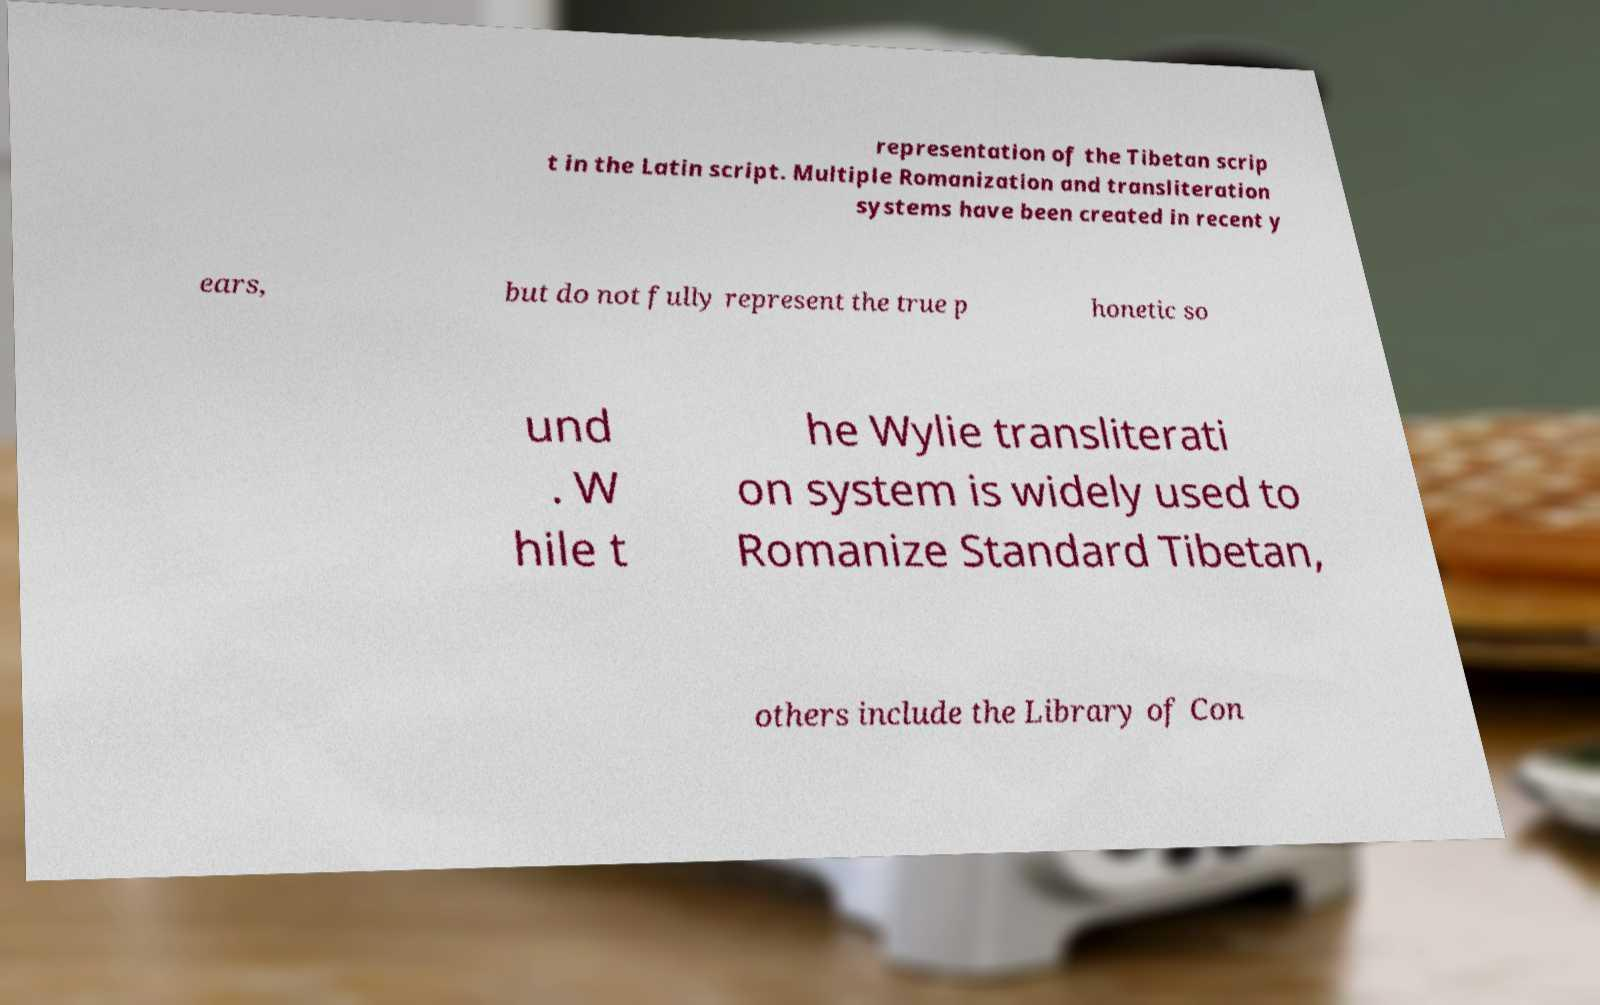For documentation purposes, I need the text within this image transcribed. Could you provide that? representation of the Tibetan scrip t in the Latin script. Multiple Romanization and transliteration systems have been created in recent y ears, but do not fully represent the true p honetic so und . W hile t he Wylie transliterati on system is widely used to Romanize Standard Tibetan, others include the Library of Con 